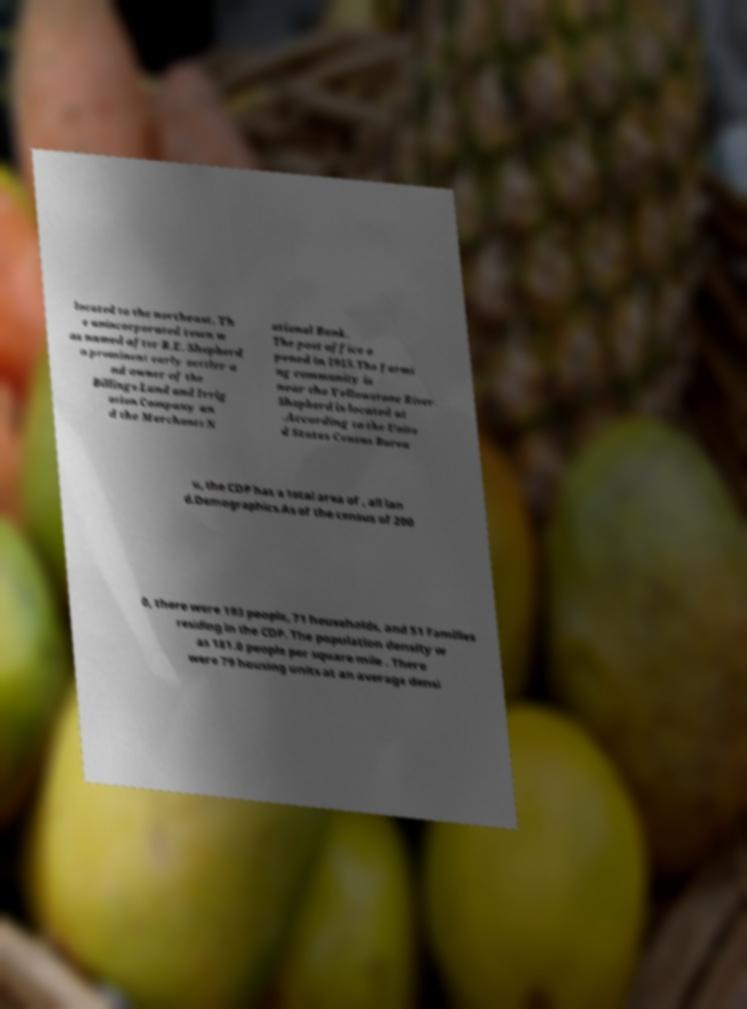I need the written content from this picture converted into text. Can you do that? located to the northeast. Th e unincorporated town w as named after R.E. Shepherd a prominent early settler a nd owner of the Billings Land and Irrig ation Company an d the Merchants N ational Bank. The post office o pened in 1915.The farmi ng community is near the Yellowstone River. Shepherd is located at .According to the Unite d States Census Burea u, the CDP has a total area of , all lan d.Demographics.As of the census of 200 0, there were 193 people, 71 households, and 51 families residing in the CDP. The population density w as 181.0 people per square mile . There were 79 housing units at an average densi 